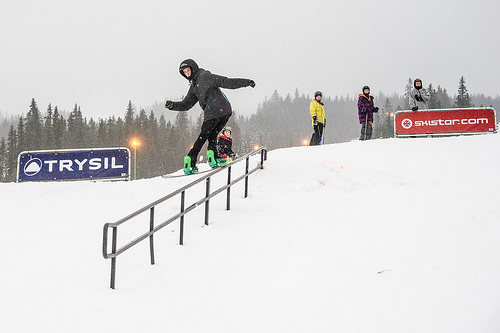What brands can you spot in this image, and where are they located? There are two visible brands in the image. 'TRYSIL' is displayed on a blue sign to the left, and 'skistar.com' on a red sign to the right. Imagine if there were giant snow creatures in this scene. What would they look like and how would they interact with the people? Imagine giant snow creatures with sparkling icy fur and gentle eyes, wandering the snowy hills. These mythical beings would be playful yet protective, building giant snow forts and helping people create intricate snow sculptures. Occasionally, they might engage in friendly snowball fights, their booming laughter echoing through the forest, creating an enchanting atmosphere for everyone nearby. 